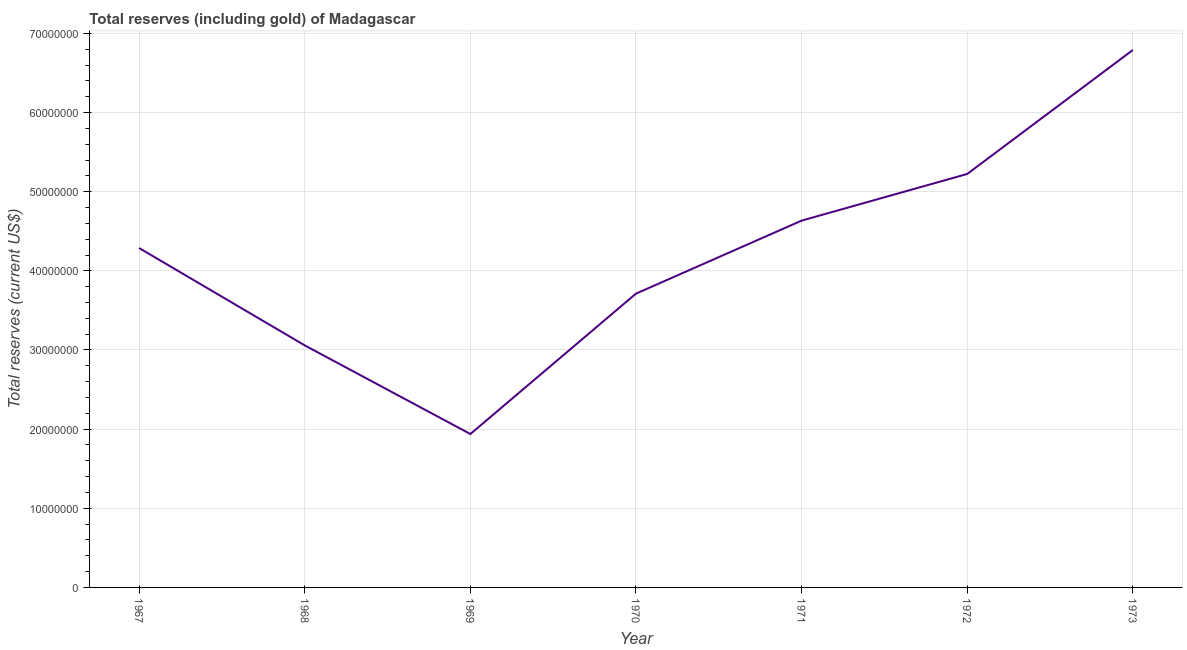What is the total reserves (including gold) in 1971?
Provide a short and direct response. 4.63e+07. Across all years, what is the maximum total reserves (including gold)?
Give a very brief answer. 6.79e+07. Across all years, what is the minimum total reserves (including gold)?
Keep it short and to the point. 1.94e+07. In which year was the total reserves (including gold) minimum?
Ensure brevity in your answer.  1969. What is the sum of the total reserves (including gold)?
Provide a succinct answer. 2.96e+08. What is the difference between the total reserves (including gold) in 1968 and 1972?
Give a very brief answer. -2.17e+07. What is the average total reserves (including gold) per year?
Ensure brevity in your answer.  4.24e+07. What is the median total reserves (including gold)?
Offer a very short reply. 4.29e+07. In how many years, is the total reserves (including gold) greater than 62000000 US$?
Provide a short and direct response. 1. What is the ratio of the total reserves (including gold) in 1970 to that in 1972?
Your response must be concise. 0.71. Is the difference between the total reserves (including gold) in 1968 and 1970 greater than the difference between any two years?
Offer a terse response. No. What is the difference between the highest and the second highest total reserves (including gold)?
Your answer should be very brief. 1.57e+07. What is the difference between the highest and the lowest total reserves (including gold)?
Provide a short and direct response. 4.85e+07. In how many years, is the total reserves (including gold) greater than the average total reserves (including gold) taken over all years?
Offer a very short reply. 4. Does the graph contain any zero values?
Give a very brief answer. No. Does the graph contain grids?
Your response must be concise. Yes. What is the title of the graph?
Give a very brief answer. Total reserves (including gold) of Madagascar. What is the label or title of the Y-axis?
Offer a terse response. Total reserves (current US$). What is the Total reserves (current US$) in 1967?
Make the answer very short. 4.29e+07. What is the Total reserves (current US$) in 1968?
Offer a terse response. 3.06e+07. What is the Total reserves (current US$) of 1969?
Offer a terse response. 1.94e+07. What is the Total reserves (current US$) in 1970?
Your answer should be very brief. 3.71e+07. What is the Total reserves (current US$) of 1971?
Your answer should be very brief. 4.63e+07. What is the Total reserves (current US$) of 1972?
Give a very brief answer. 5.22e+07. What is the Total reserves (current US$) of 1973?
Make the answer very short. 6.79e+07. What is the difference between the Total reserves (current US$) in 1967 and 1968?
Provide a succinct answer. 1.23e+07. What is the difference between the Total reserves (current US$) in 1967 and 1969?
Provide a succinct answer. 2.35e+07. What is the difference between the Total reserves (current US$) in 1967 and 1970?
Give a very brief answer. 5.76e+06. What is the difference between the Total reserves (current US$) in 1967 and 1971?
Offer a terse response. -3.46e+06. What is the difference between the Total reserves (current US$) in 1967 and 1972?
Offer a terse response. -9.36e+06. What is the difference between the Total reserves (current US$) in 1967 and 1973?
Keep it short and to the point. -2.50e+07. What is the difference between the Total reserves (current US$) in 1968 and 1969?
Provide a succinct answer. 1.12e+07. What is the difference between the Total reserves (current US$) in 1968 and 1970?
Your answer should be compact. -6.54e+06. What is the difference between the Total reserves (current US$) in 1968 and 1971?
Offer a terse response. -1.58e+07. What is the difference between the Total reserves (current US$) in 1968 and 1972?
Your answer should be compact. -2.17e+07. What is the difference between the Total reserves (current US$) in 1968 and 1973?
Give a very brief answer. -3.73e+07. What is the difference between the Total reserves (current US$) in 1969 and 1970?
Your answer should be very brief. -1.77e+07. What is the difference between the Total reserves (current US$) in 1969 and 1971?
Ensure brevity in your answer.  -2.70e+07. What is the difference between the Total reserves (current US$) in 1969 and 1972?
Offer a terse response. -3.29e+07. What is the difference between the Total reserves (current US$) in 1969 and 1973?
Give a very brief answer. -4.85e+07. What is the difference between the Total reserves (current US$) in 1970 and 1971?
Offer a terse response. -9.22e+06. What is the difference between the Total reserves (current US$) in 1970 and 1972?
Offer a terse response. -1.51e+07. What is the difference between the Total reserves (current US$) in 1970 and 1973?
Your answer should be very brief. -3.08e+07. What is the difference between the Total reserves (current US$) in 1971 and 1972?
Offer a terse response. -5.90e+06. What is the difference between the Total reserves (current US$) in 1971 and 1973?
Your answer should be compact. -2.16e+07. What is the difference between the Total reserves (current US$) in 1972 and 1973?
Your answer should be very brief. -1.57e+07. What is the ratio of the Total reserves (current US$) in 1967 to that in 1968?
Your answer should be very brief. 1.4. What is the ratio of the Total reserves (current US$) in 1967 to that in 1969?
Ensure brevity in your answer.  2.21. What is the ratio of the Total reserves (current US$) in 1967 to that in 1970?
Give a very brief answer. 1.16. What is the ratio of the Total reserves (current US$) in 1967 to that in 1971?
Your answer should be very brief. 0.93. What is the ratio of the Total reserves (current US$) in 1967 to that in 1972?
Your answer should be very brief. 0.82. What is the ratio of the Total reserves (current US$) in 1967 to that in 1973?
Offer a very short reply. 0.63. What is the ratio of the Total reserves (current US$) in 1968 to that in 1969?
Your answer should be very brief. 1.58. What is the ratio of the Total reserves (current US$) in 1968 to that in 1970?
Keep it short and to the point. 0.82. What is the ratio of the Total reserves (current US$) in 1968 to that in 1971?
Provide a short and direct response. 0.66. What is the ratio of the Total reserves (current US$) in 1968 to that in 1972?
Your answer should be very brief. 0.58. What is the ratio of the Total reserves (current US$) in 1968 to that in 1973?
Offer a very short reply. 0.45. What is the ratio of the Total reserves (current US$) in 1969 to that in 1970?
Make the answer very short. 0.52. What is the ratio of the Total reserves (current US$) in 1969 to that in 1971?
Give a very brief answer. 0.42. What is the ratio of the Total reserves (current US$) in 1969 to that in 1972?
Your answer should be very brief. 0.37. What is the ratio of the Total reserves (current US$) in 1969 to that in 1973?
Keep it short and to the point. 0.28. What is the ratio of the Total reserves (current US$) in 1970 to that in 1971?
Offer a very short reply. 0.8. What is the ratio of the Total reserves (current US$) in 1970 to that in 1972?
Provide a succinct answer. 0.71. What is the ratio of the Total reserves (current US$) in 1970 to that in 1973?
Your response must be concise. 0.55. What is the ratio of the Total reserves (current US$) in 1971 to that in 1972?
Make the answer very short. 0.89. What is the ratio of the Total reserves (current US$) in 1971 to that in 1973?
Ensure brevity in your answer.  0.68. What is the ratio of the Total reserves (current US$) in 1972 to that in 1973?
Your answer should be very brief. 0.77. 